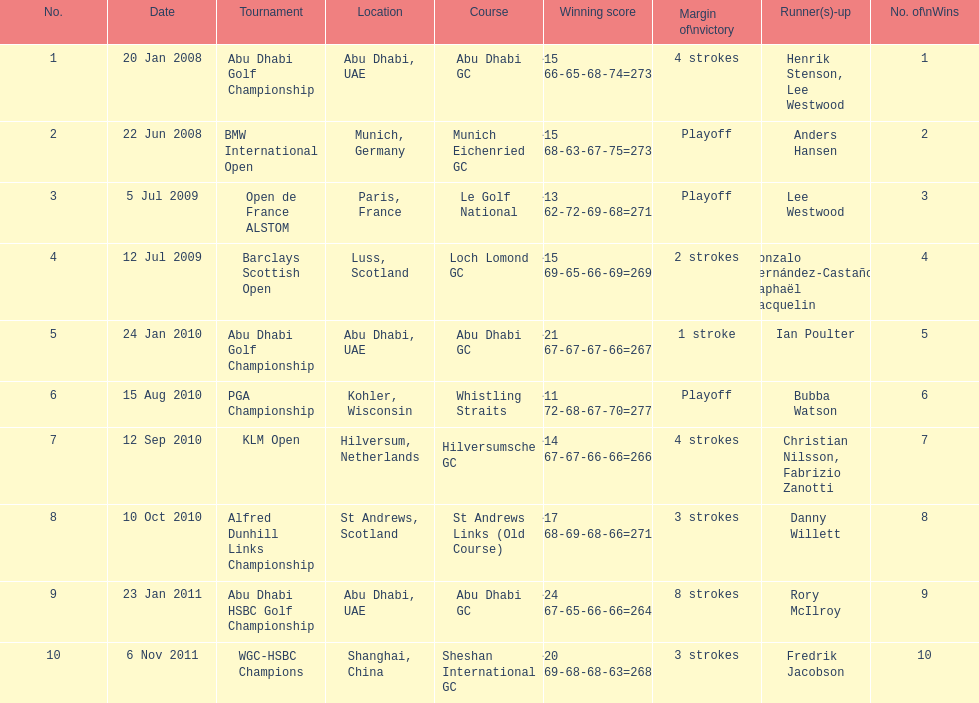Who had the top score in the pga championship? Bubba Watson. 